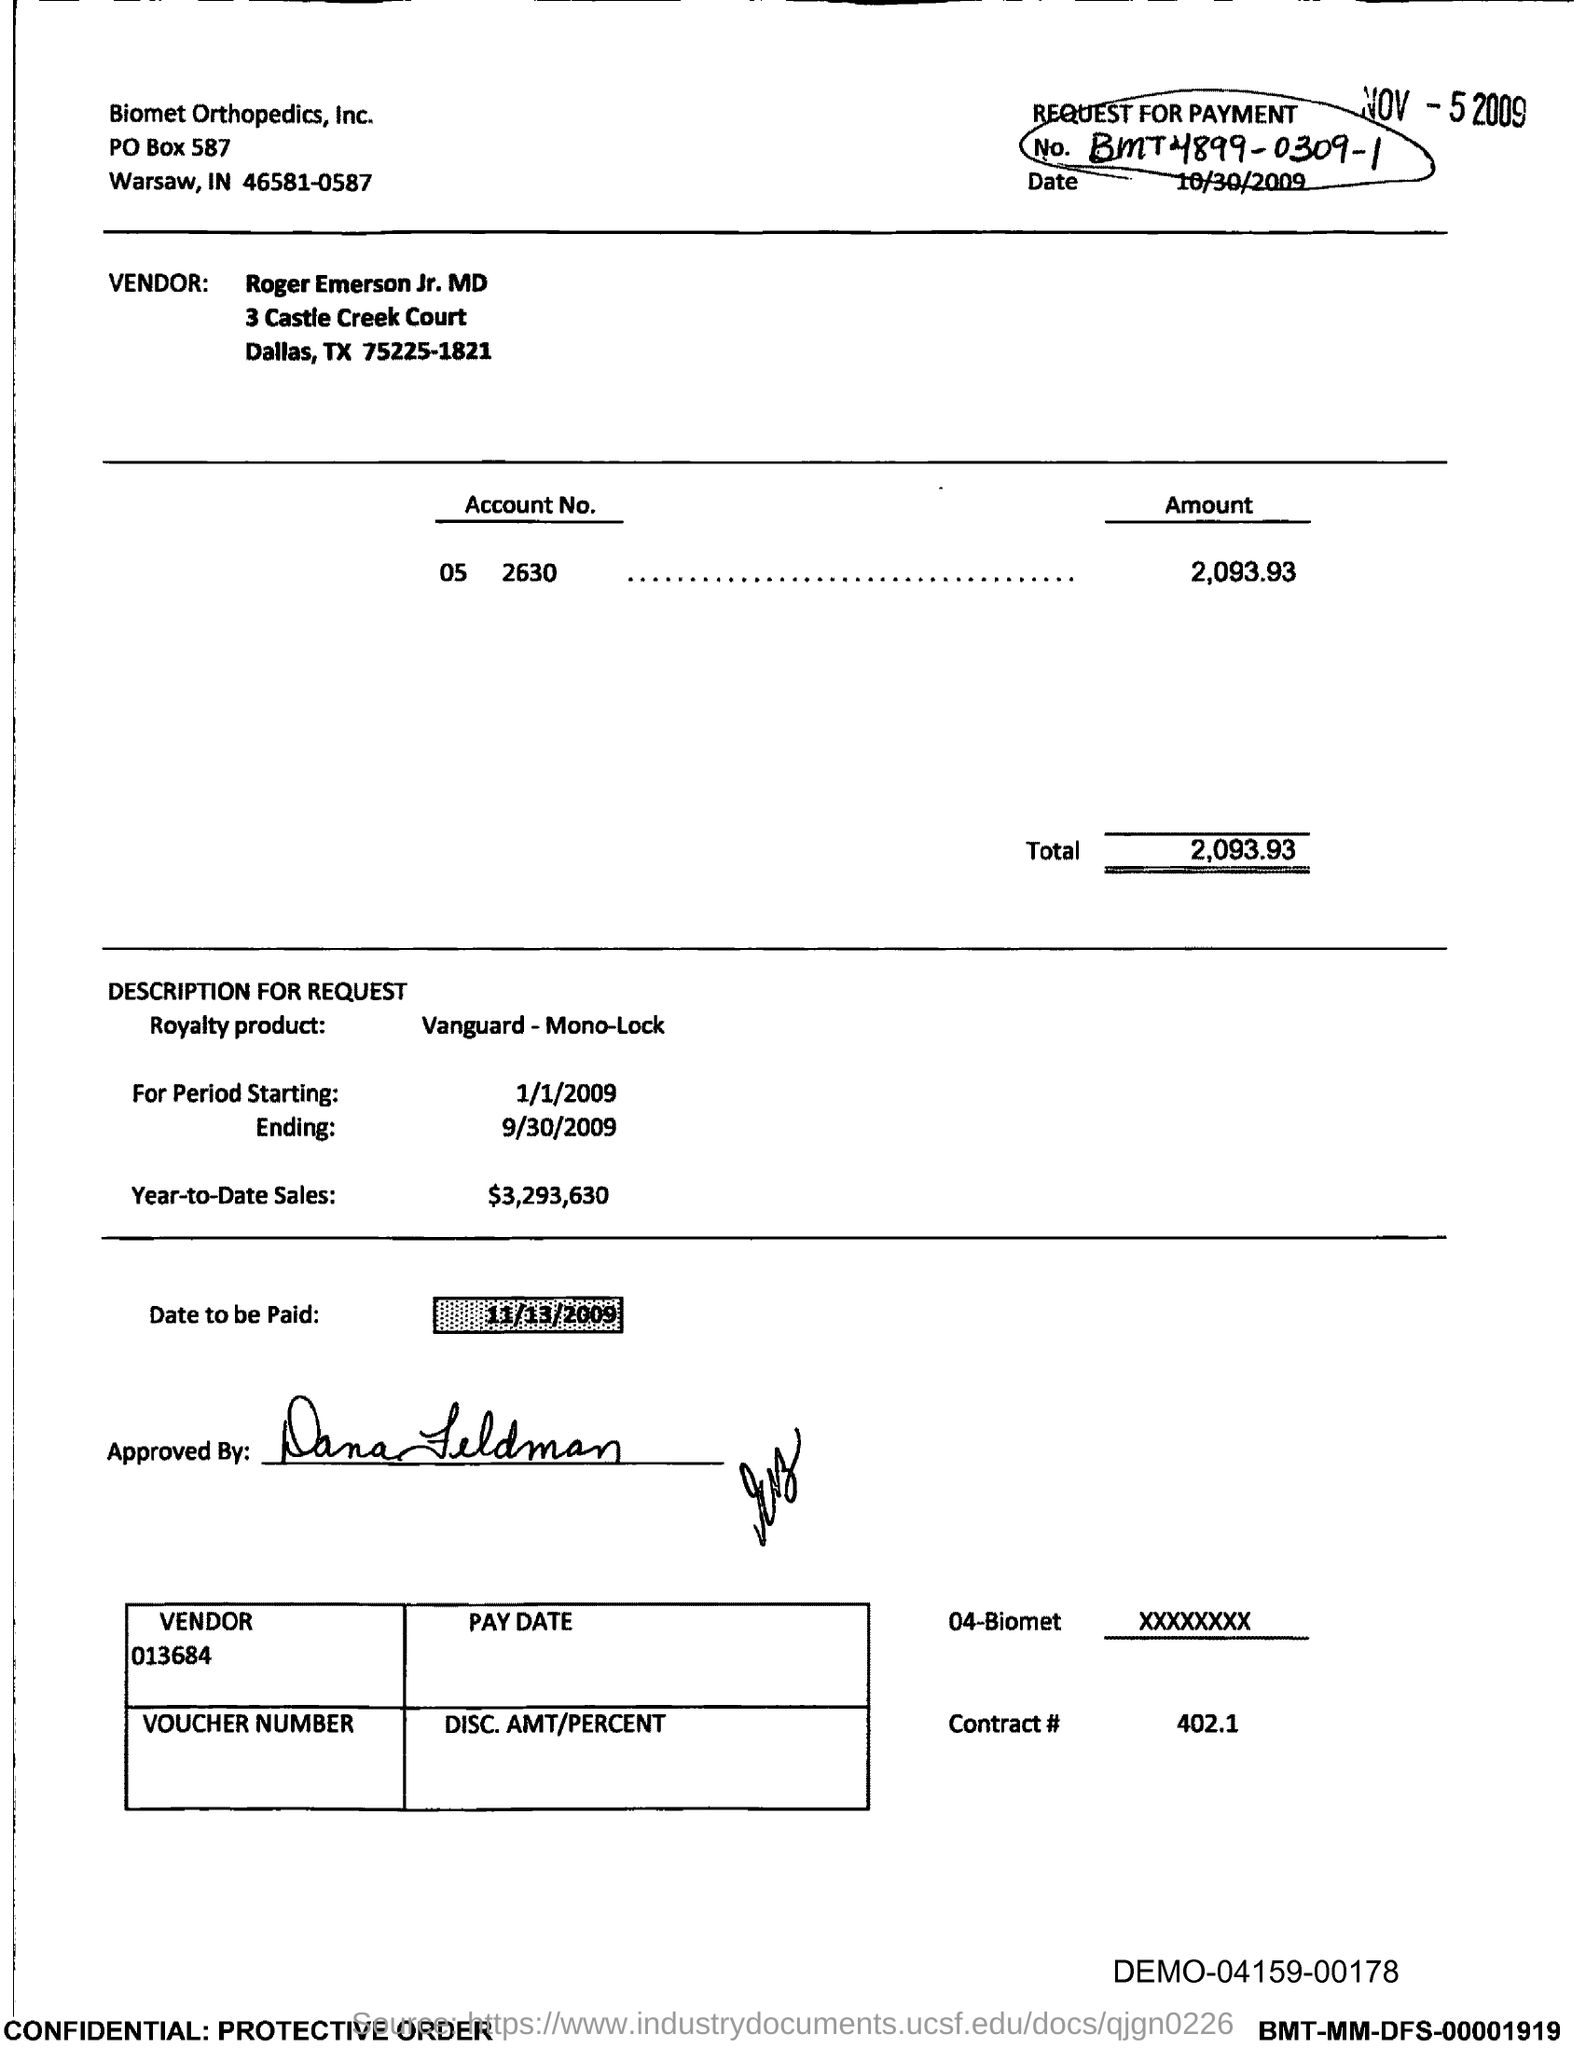Who is the vendor?
Your response must be concise. Roger Emerson Jr. MD. What is the document about?
Provide a short and direct response. REQUEST FOR PAYMENT. What is the amount in the account?
Make the answer very short. 2,093.93. When is the date to be paid?
Give a very brief answer. 11/13/2009. What is the contract #?
Give a very brief answer. 402.1. 